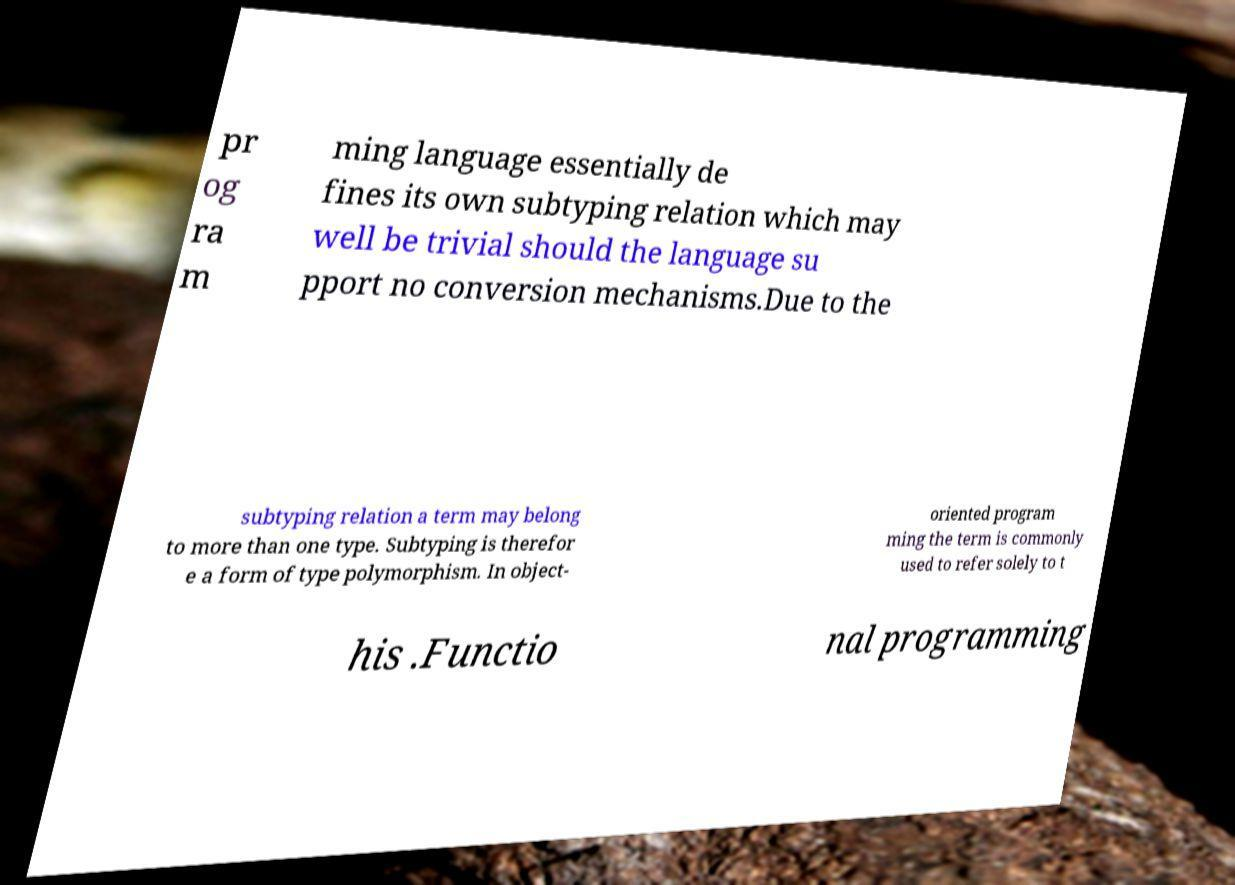There's text embedded in this image that I need extracted. Can you transcribe it verbatim? pr og ra m ming language essentially de fines its own subtyping relation which may well be trivial should the language su pport no conversion mechanisms.Due to the subtyping relation a term may belong to more than one type. Subtyping is therefor e a form of type polymorphism. In object- oriented program ming the term is commonly used to refer solely to t his .Functio nal programming 